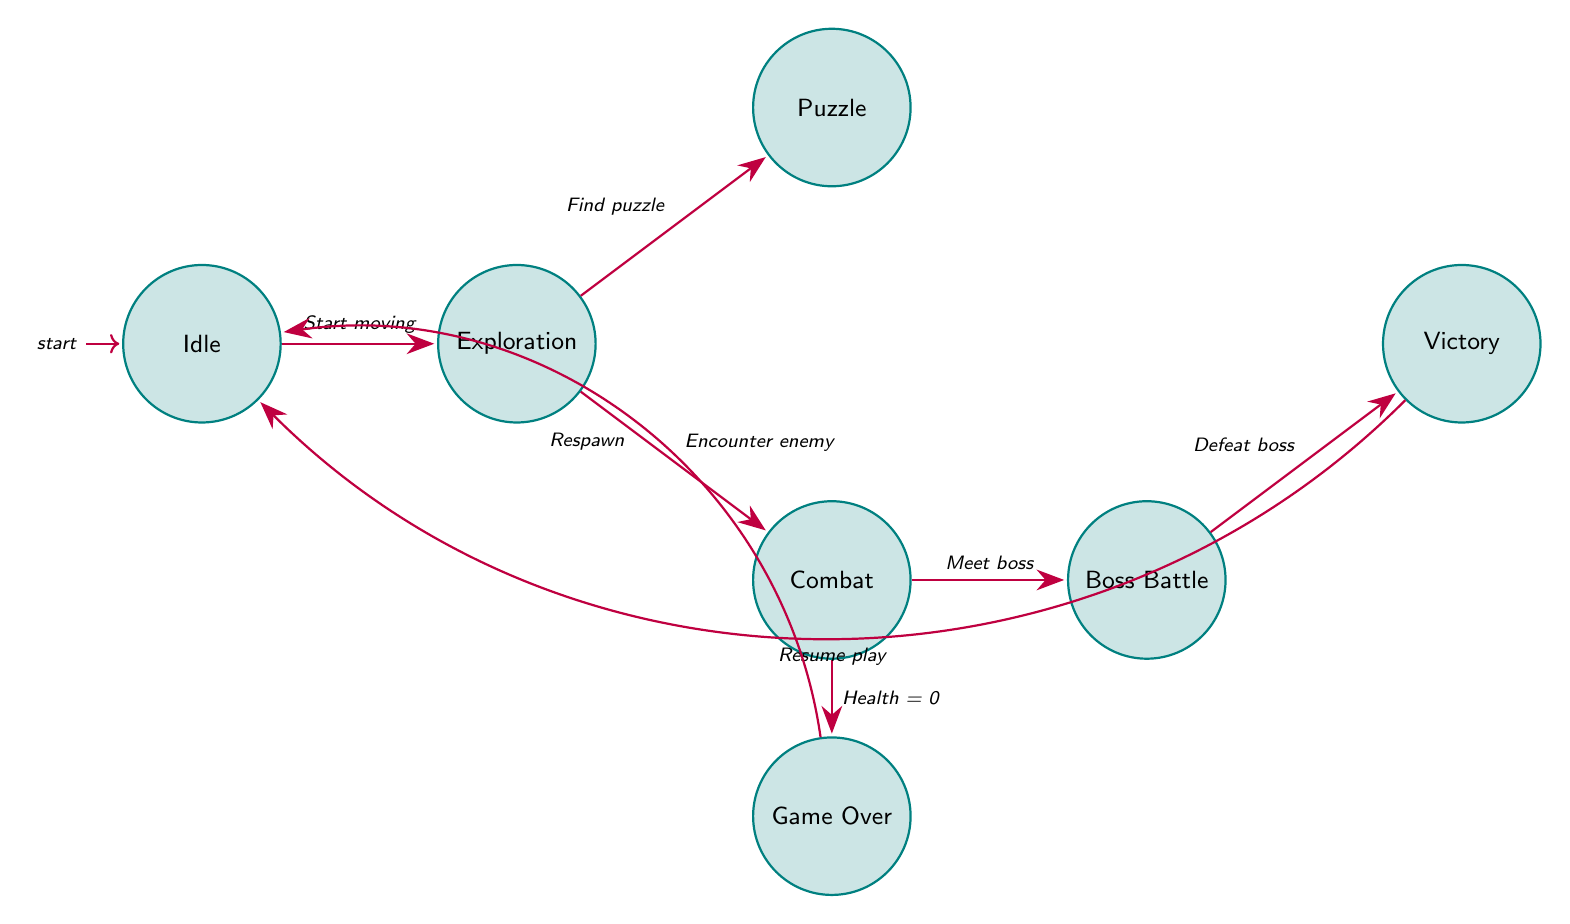What is the initial state in the diagram? The initial state is represented by the node with the "initial" label, which is "Idle" in this case.
Answer: Idle How many states are there in total? By counting the distinct nodes in the diagram, there are seven states listed: Idle, Exploration, Combat, Puzzle, Boss Battle, Victory, and Game Over.
Answer: 7 What transition occurs from Exploration to Puzzle? The transition from Exploration to Puzzle occurs when the player starts interacting with a puzzle mechanism, as described in the diagram.
Answer: Find puzzle Which state follows Combat if the player's health reaches zero? The state that follows Combat when the player's health reaches zero is Game Over accordingly.
Answer: Game Over What condition leads from Boss Battle to Victory? The condition that leads from Boss Battle to Victory is when the player defeats the boss, which is a key event in the transition.
Answer: Defeat boss If the player starts moving, which state does it transition to? The player transitions to the Exploration state when they start moving around, marking their engagement with the game environment.
Answer: Exploration How many edges are connected to the Combat state? The edges connected to the Combat state include those leading to Boss Battle and Game Over, making a total of two transitions originating from Combat.
Answer: 2 What is the last state before returning to Idle? The last state before returning to Idle is Victory, after which the player resumes normal gameplay following a celebration.
Answer: Victory What transition occurs if the player resumes play from Victory? The transition that occurs if the player resumes play from Victory is back to the Idle state, indicating a return to non-engagement.
Answer: Resume play 